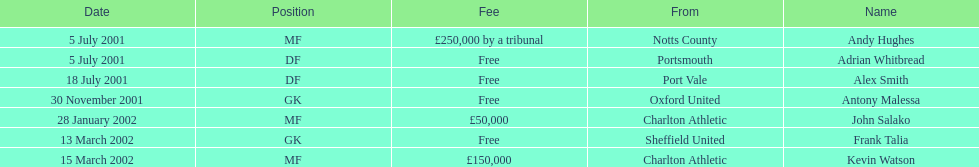Who received the bigger fee, andy hughes or john salako? Andy Hughes. 